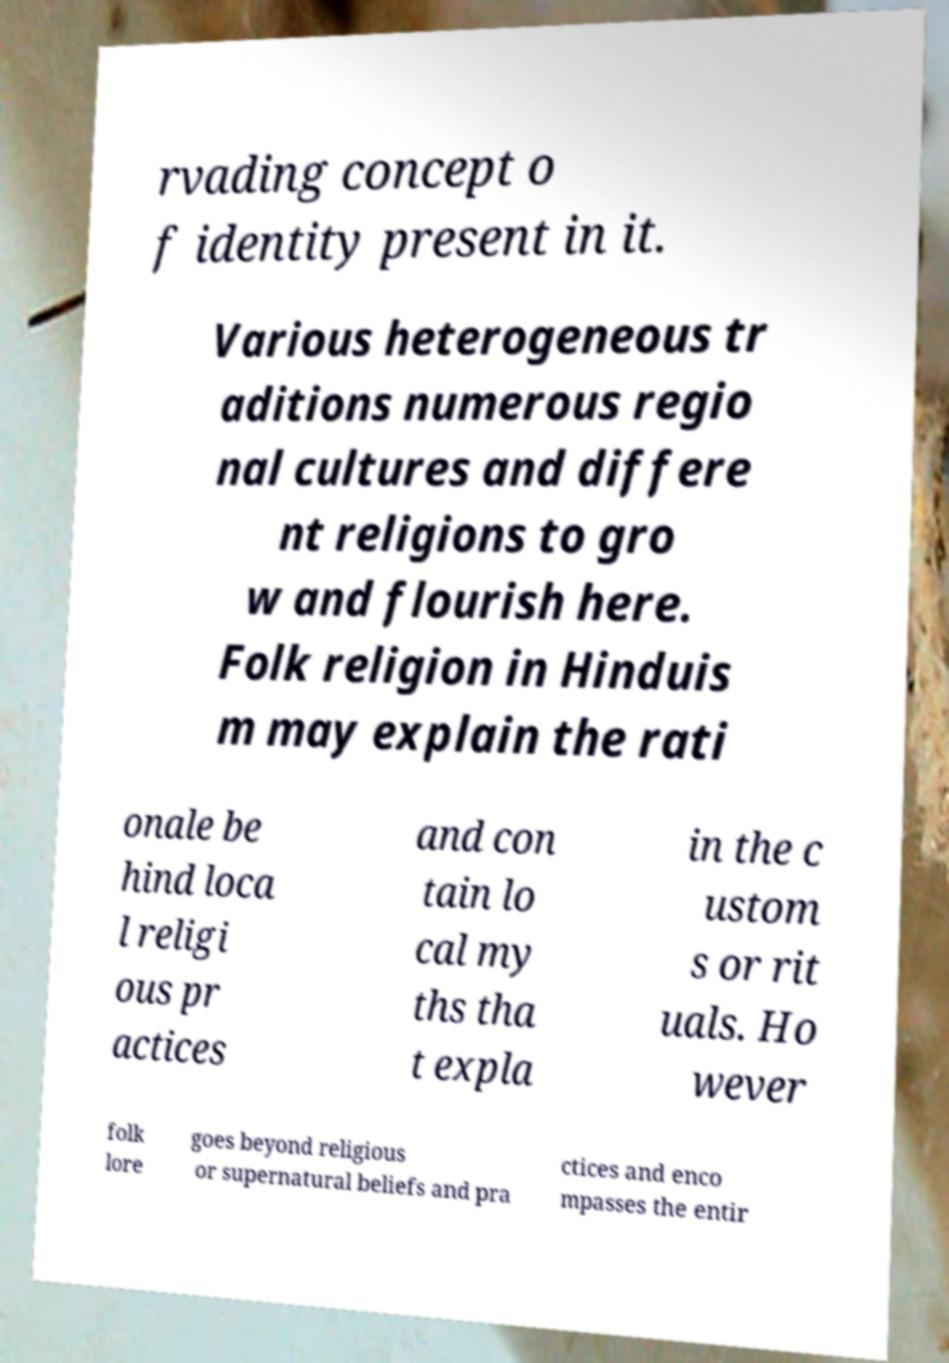There's text embedded in this image that I need extracted. Can you transcribe it verbatim? rvading concept o f identity present in it. Various heterogeneous tr aditions numerous regio nal cultures and differe nt religions to gro w and flourish here. Folk religion in Hinduis m may explain the rati onale be hind loca l religi ous pr actices and con tain lo cal my ths tha t expla in the c ustom s or rit uals. Ho wever folk lore goes beyond religious or supernatural beliefs and pra ctices and enco mpasses the entir 